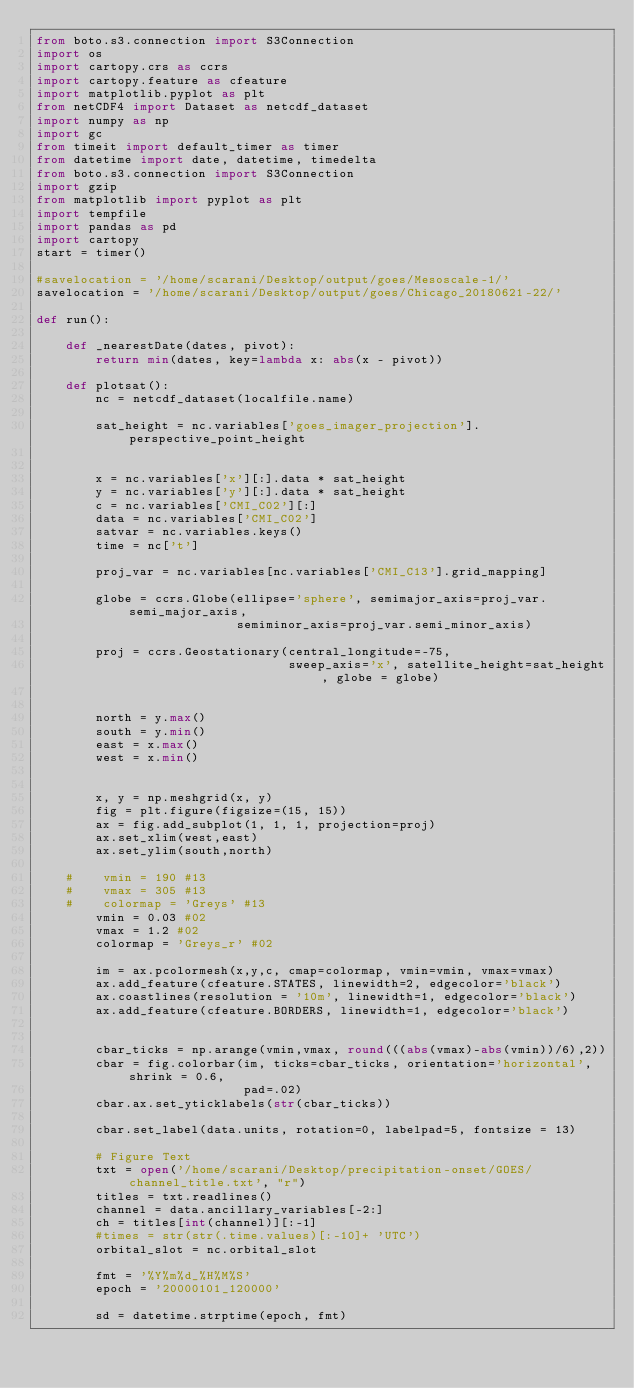<code> <loc_0><loc_0><loc_500><loc_500><_Python_>from boto.s3.connection import S3Connection
import os
import cartopy.crs as ccrs
import cartopy.feature as cfeature
import matplotlib.pyplot as plt
from netCDF4 import Dataset as netcdf_dataset
import numpy as np
import gc
from timeit import default_timer as timer
from datetime import date, datetime, timedelta
from boto.s3.connection import S3Connection
import gzip
from matplotlib import pyplot as plt
import tempfile
import pandas as pd
import cartopy
start = timer()

#savelocation = '/home/scarani/Desktop/output/goes/Mesoscale-1/'
savelocation = '/home/scarani/Desktop/output/goes/Chicago_20180621-22/'

def run():

    def _nearestDate(dates, pivot):
        return min(dates, key=lambda x: abs(x - pivot))
    
    def plotsat():
        nc = netcdf_dataset(localfile.name)
        
        sat_height = nc.variables['goes_imager_projection'].perspective_point_height
        
        
        x = nc.variables['x'][:].data * sat_height
        y = nc.variables['y'][:].data * sat_height
        c = nc.variables['CMI_C02'][:]
        data = nc.variables['CMI_C02']
        satvar = nc.variables.keys()
        time = nc['t']
        
        proj_var = nc.variables[nc.variables['CMI_C13'].grid_mapping]
        
        globe = ccrs.Globe(ellipse='sphere', semimajor_axis=proj_var.semi_major_axis,
                           semiminor_axis=proj_var.semi_minor_axis)
        
        proj = ccrs.Geostationary(central_longitude=-75,
                                  sweep_axis='x', satellite_height=sat_height, globe = globe)
        
        
        north = y.max()
        south = y.min()
        east = x.max()
        west = x.min()
        
        
        x, y = np.meshgrid(x, y)
        fig = plt.figure(figsize=(15, 15))
        ax = fig.add_subplot(1, 1, 1, projection=proj)
        ax.set_xlim(west,east)
        ax.set_ylim(south,north)
        
    #    vmin = 190 #13
    #    vmax = 305 #13
    #    colormap = 'Greys' #13
        vmin = 0.03 #02
        vmax = 1.2 #02
        colormap = 'Greys_r' #02
        
        im = ax.pcolormesh(x,y,c, cmap=colormap, vmin=vmin, vmax=vmax)
        ax.add_feature(cfeature.STATES, linewidth=2, edgecolor='black')
        ax.coastlines(resolution = '10m', linewidth=1, edgecolor='black')
        ax.add_feature(cfeature.BORDERS, linewidth=1, edgecolor='black')
        
        
        cbar_ticks = np.arange(vmin,vmax, round(((abs(vmax)-abs(vmin))/6),2))
        cbar = fig.colorbar(im, ticks=cbar_ticks, orientation='horizontal', shrink = 0.6,
                            pad=.02)
        cbar.ax.set_yticklabels(str(cbar_ticks))
        
        cbar.set_label(data.units, rotation=0, labelpad=5, fontsize = 13)
        
        # Figure Text
        txt = open('/home/scarani/Desktop/precipitation-onset/GOES/channel_title.txt', "r")
        titles = txt.readlines()
        channel = data.ancillary_variables[-2:]
        ch = titles[int(channel)][:-1]
        #times = str(str(.time.values)[:-10]+ 'UTC')
        orbital_slot = nc.orbital_slot
        
        fmt = '%Y%m%d_%H%M%S'
        epoch = '20000101_120000'
        
        sd = datetime.strptime(epoch, fmt)</code> 